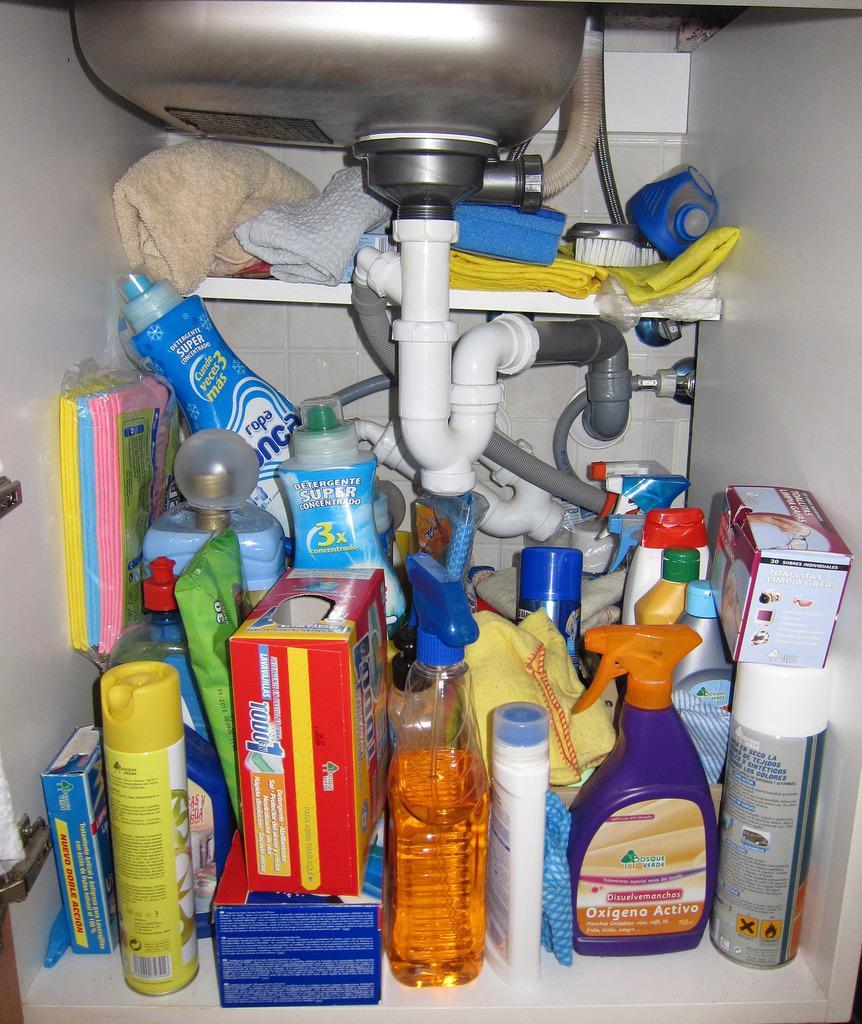Describe this image in one or two sentences. There are some articles under the sink which are improperly arranged. 